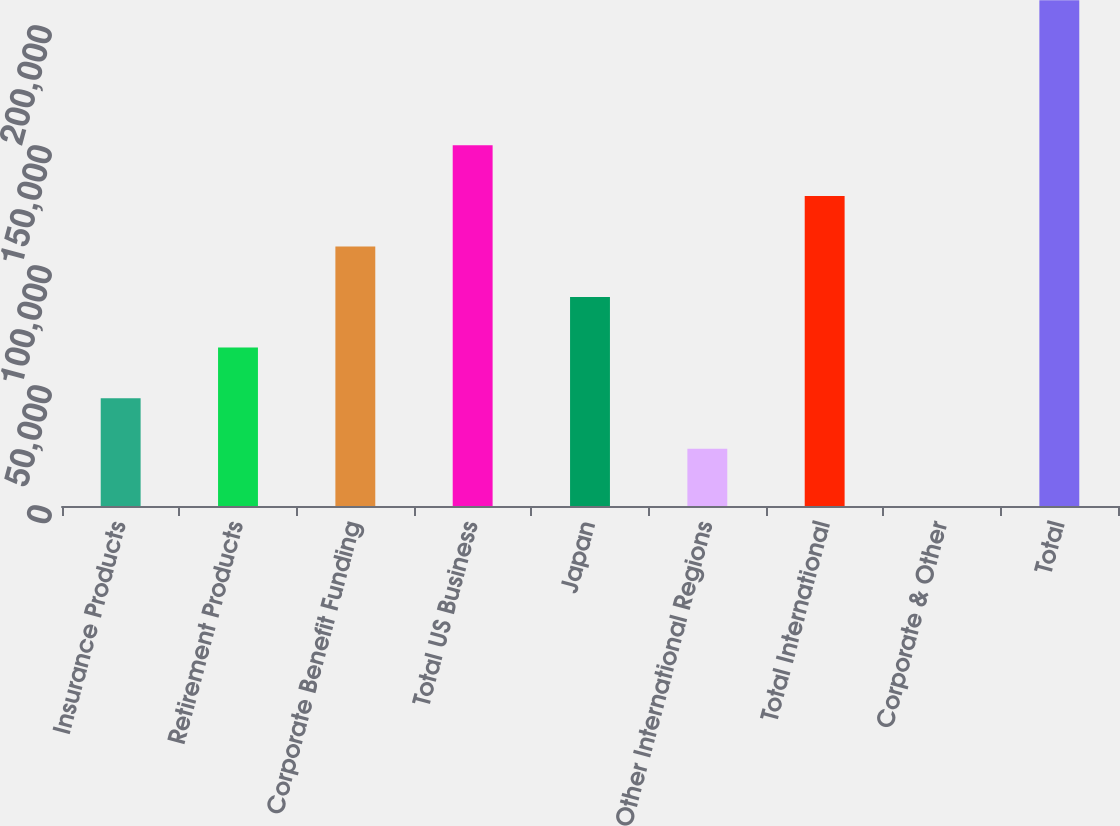Convert chart to OTSL. <chart><loc_0><loc_0><loc_500><loc_500><bar_chart><fcel>Insurance Products<fcel>Retirement Products<fcel>Corporate Benefit Funding<fcel>Total US Business<fcel>Japan<fcel>Other International Regions<fcel>Total International<fcel>Corporate & Other<fcel>Total<nl><fcel>44928.5<fcel>66000<fcel>108143<fcel>150286<fcel>87071.5<fcel>23857<fcel>129214<fcel>42<fcel>210757<nl></chart> 